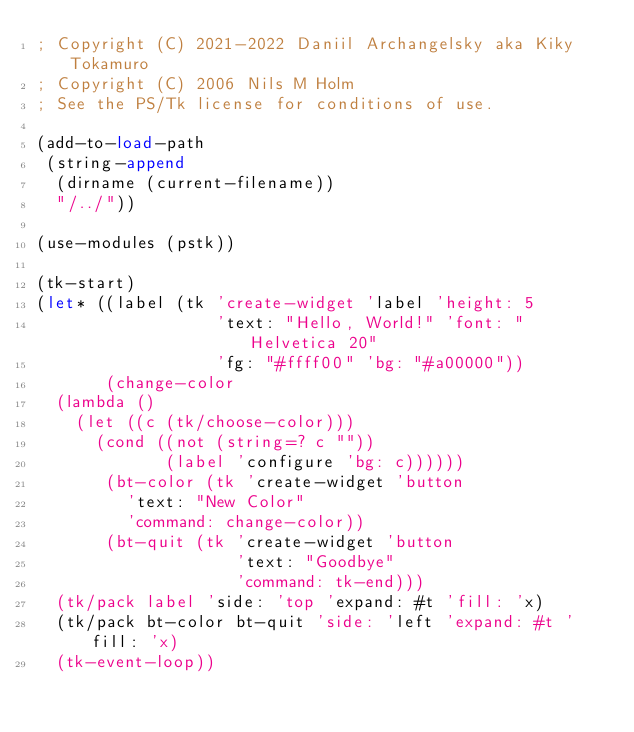<code> <loc_0><loc_0><loc_500><loc_500><_Scheme_>; Copyright (C) 2021-2022 Daniil Archangelsky aka Kiky Tokamuro
; Copyright (C) 2006 Nils M Holm
; See the PS/Tk license for conditions of use.

(add-to-load-path
 (string-append
  (dirname (current-filename))
  "/../"))

(use-modules (pstk))

(tk-start)
(let* ((label (tk 'create-widget 'label 'height: 5
                  'text: "Hello, World!" 'font: "Helvetica 20"
                  'fg: "#ffff00" 'bg: "#a00000"))
       (change-color
	(lambda ()
	  (let ((c (tk/choose-color)))
	    (cond ((not (string=? c ""))
	           (label 'configure 'bg: c))))))
       (bt-color (tk 'create-widget 'button
		     'text: "New Color"
		     'command: change-color))
       (bt-quit (tk 'create-widget 'button
                    'text: "Goodbye"
                    'command: tk-end)))
  (tk/pack label 'side: 'top 'expand: #t 'fill: 'x)
  (tk/pack bt-color bt-quit 'side: 'left 'expand: #t 'fill: 'x)
  (tk-event-loop))
</code> 